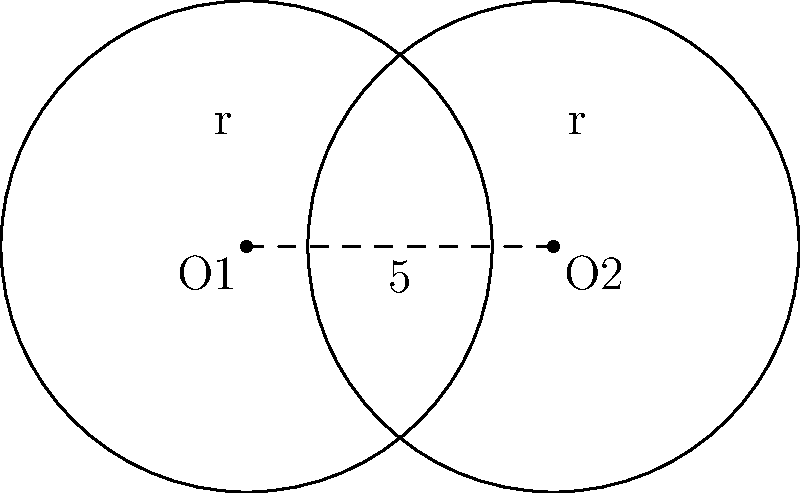Two circular surveillance sensors are placed 5 units apart, each with a radius of 4 units. Calculate the area of the overlapping region to determine the optimal coverage for a covert operation. Round your answer to two decimal places. To find the area of overlap between two circles, we can use the following steps:

1) First, we need to calculate the distance between the centers of the circles:
   $d = 5$ (given in the problem)

2) The radius of each circle:
   $r = 4$

3) To find the area of overlap, we use the formula:
   $$A = 2r^2 \arccos(\frac{d}{2r}) - d\sqrt{r^2 - (\frac{d}{2})^2}$$

4) Let's substitute our values:
   $$A = 2(4^2) \arccos(\frac{5}{2(4)}) - 5\sqrt{4^2 - (\frac{5}{2})^2}$$

5) Simplify:
   $$A = 32 \arccos(\frac{5}{8}) - 5\sqrt{16 - 6.25}$$
   $$A = 32 \arccos(0.625) - 5\sqrt{9.75}$$

6) Calculate:
   $$A \approx 32(0.8927) - 5(3.1225)$$
   $$A \approx 28.5664 - 15.6125$$
   $$A \approx 12.9539$$

7) Rounding to two decimal places:
   $$A \approx 12.95$$

This area represents the optimal coverage zone where both sensors overlap, providing enhanced surveillance capabilities for the covert operation.
Answer: 12.95 square units 